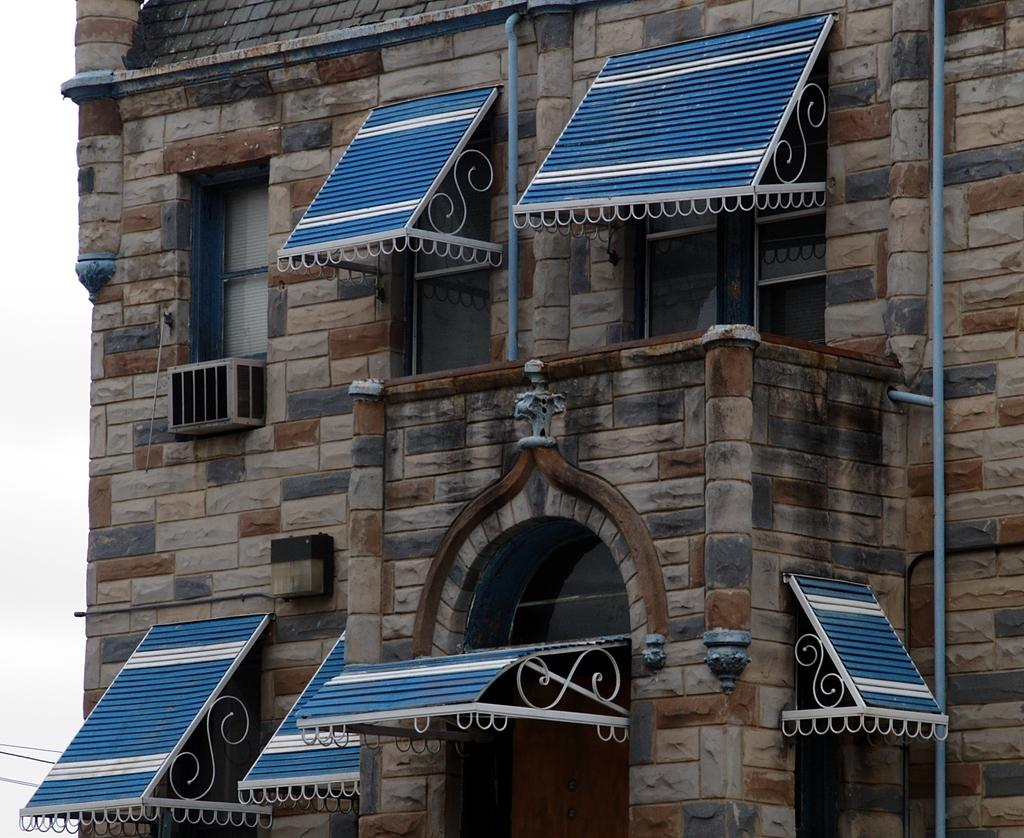What is the main structure in the image? There is a building in the image. What feature can be seen on the building? The building has windows. What is covering the windows? Blue color boards are present on the windows. What part of the natural environment is visible in the image? The sky is visible on the left side of the image. Can you tell me how many flocks of birds are flying in the image? There are no birds or flocks visible in the image; it only features a building with windows covered by blue color boards. What type of seed is being planted in the image? There is no seed or planting activity depicted in the image. 